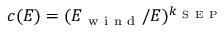<formula> <loc_0><loc_0><loc_500><loc_500>c ( E ) = ( E _ { w i n d } / E ) ^ { k _ { S E P } }</formula> 